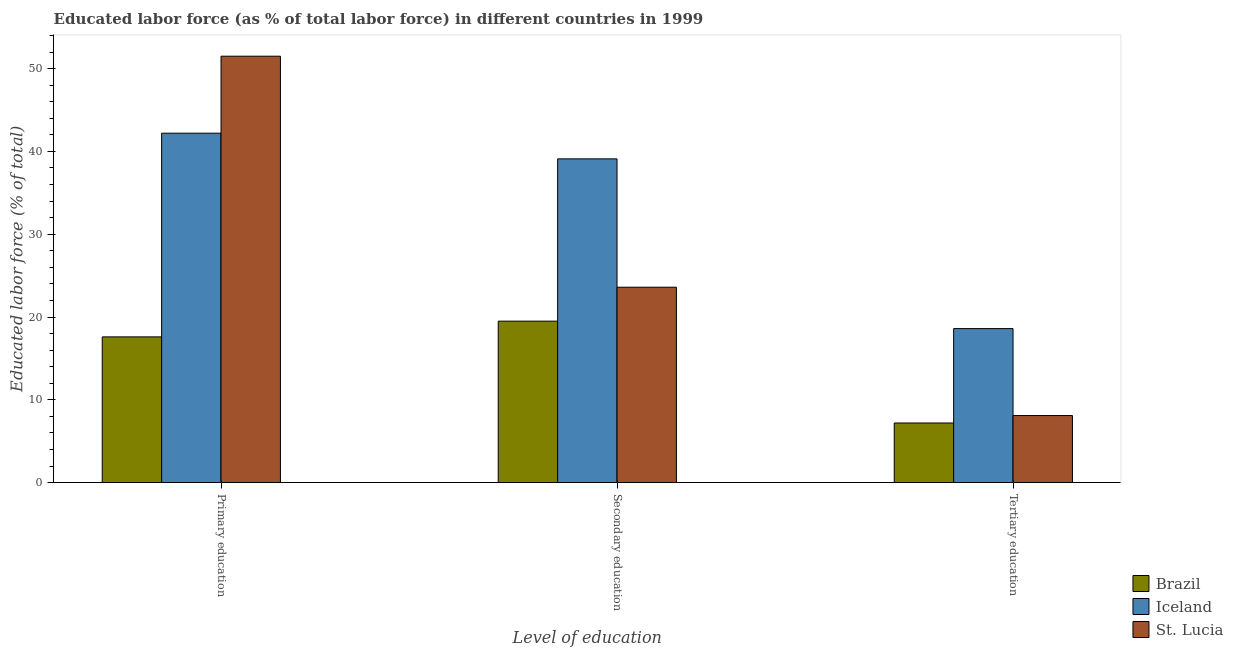How many different coloured bars are there?
Ensure brevity in your answer.  3. What is the label of the 2nd group of bars from the left?
Keep it short and to the point. Secondary education. What is the percentage of labor force who received primary education in Iceland?
Provide a succinct answer. 42.2. Across all countries, what is the maximum percentage of labor force who received tertiary education?
Provide a short and direct response. 18.6. In which country was the percentage of labor force who received tertiary education minimum?
Your answer should be very brief. Brazil. What is the total percentage of labor force who received primary education in the graph?
Your answer should be compact. 111.3. What is the difference between the percentage of labor force who received secondary education in Iceland and that in Brazil?
Your answer should be very brief. 19.6. What is the difference between the percentage of labor force who received primary education in Iceland and the percentage of labor force who received secondary education in St. Lucia?
Offer a terse response. 18.6. What is the average percentage of labor force who received tertiary education per country?
Offer a very short reply. 11.3. What is the difference between the percentage of labor force who received primary education and percentage of labor force who received secondary education in Iceland?
Keep it short and to the point. 3.1. What is the ratio of the percentage of labor force who received secondary education in Iceland to that in St. Lucia?
Make the answer very short. 1.66. Is the difference between the percentage of labor force who received primary education in Brazil and St. Lucia greater than the difference between the percentage of labor force who received tertiary education in Brazil and St. Lucia?
Keep it short and to the point. No. What is the difference between the highest and the second highest percentage of labor force who received primary education?
Keep it short and to the point. 9.3. What is the difference between the highest and the lowest percentage of labor force who received secondary education?
Give a very brief answer. 19.6. What does the 1st bar from the left in Tertiary education represents?
Offer a terse response. Brazil. What does the 1st bar from the right in Secondary education represents?
Keep it short and to the point. St. Lucia. Are all the bars in the graph horizontal?
Provide a short and direct response. No. Are the values on the major ticks of Y-axis written in scientific E-notation?
Your answer should be compact. No. Does the graph contain any zero values?
Provide a short and direct response. No. Where does the legend appear in the graph?
Your response must be concise. Bottom right. How many legend labels are there?
Make the answer very short. 3. What is the title of the graph?
Provide a succinct answer. Educated labor force (as % of total labor force) in different countries in 1999. Does "Guinea-Bissau" appear as one of the legend labels in the graph?
Your answer should be compact. No. What is the label or title of the X-axis?
Ensure brevity in your answer.  Level of education. What is the label or title of the Y-axis?
Provide a succinct answer. Educated labor force (% of total). What is the Educated labor force (% of total) of Brazil in Primary education?
Provide a succinct answer. 17.6. What is the Educated labor force (% of total) in Iceland in Primary education?
Provide a short and direct response. 42.2. What is the Educated labor force (% of total) of St. Lucia in Primary education?
Offer a very short reply. 51.5. What is the Educated labor force (% of total) of Iceland in Secondary education?
Provide a succinct answer. 39.1. What is the Educated labor force (% of total) of St. Lucia in Secondary education?
Make the answer very short. 23.6. What is the Educated labor force (% of total) of Brazil in Tertiary education?
Your answer should be compact. 7.2. What is the Educated labor force (% of total) in Iceland in Tertiary education?
Give a very brief answer. 18.6. What is the Educated labor force (% of total) in St. Lucia in Tertiary education?
Offer a very short reply. 8.1. Across all Level of education, what is the maximum Educated labor force (% of total) in Brazil?
Make the answer very short. 19.5. Across all Level of education, what is the maximum Educated labor force (% of total) in Iceland?
Ensure brevity in your answer.  42.2. Across all Level of education, what is the maximum Educated labor force (% of total) in St. Lucia?
Offer a terse response. 51.5. Across all Level of education, what is the minimum Educated labor force (% of total) of Brazil?
Offer a terse response. 7.2. Across all Level of education, what is the minimum Educated labor force (% of total) in Iceland?
Provide a short and direct response. 18.6. Across all Level of education, what is the minimum Educated labor force (% of total) of St. Lucia?
Make the answer very short. 8.1. What is the total Educated labor force (% of total) in Brazil in the graph?
Offer a very short reply. 44.3. What is the total Educated labor force (% of total) of Iceland in the graph?
Your answer should be compact. 99.9. What is the total Educated labor force (% of total) of St. Lucia in the graph?
Ensure brevity in your answer.  83.2. What is the difference between the Educated labor force (% of total) in Brazil in Primary education and that in Secondary education?
Ensure brevity in your answer.  -1.9. What is the difference between the Educated labor force (% of total) of St. Lucia in Primary education and that in Secondary education?
Your answer should be very brief. 27.9. What is the difference between the Educated labor force (% of total) of Iceland in Primary education and that in Tertiary education?
Offer a terse response. 23.6. What is the difference between the Educated labor force (% of total) of St. Lucia in Primary education and that in Tertiary education?
Your answer should be compact. 43.4. What is the difference between the Educated labor force (% of total) of Brazil in Secondary education and that in Tertiary education?
Your response must be concise. 12.3. What is the difference between the Educated labor force (% of total) in Iceland in Secondary education and that in Tertiary education?
Make the answer very short. 20.5. What is the difference between the Educated labor force (% of total) of Brazil in Primary education and the Educated labor force (% of total) of Iceland in Secondary education?
Your answer should be compact. -21.5. What is the difference between the Educated labor force (% of total) in Brazil in Primary education and the Educated labor force (% of total) in Iceland in Tertiary education?
Your response must be concise. -1. What is the difference between the Educated labor force (% of total) in Iceland in Primary education and the Educated labor force (% of total) in St. Lucia in Tertiary education?
Your answer should be compact. 34.1. What is the difference between the Educated labor force (% of total) of Iceland in Secondary education and the Educated labor force (% of total) of St. Lucia in Tertiary education?
Your answer should be very brief. 31. What is the average Educated labor force (% of total) in Brazil per Level of education?
Your response must be concise. 14.77. What is the average Educated labor force (% of total) of Iceland per Level of education?
Give a very brief answer. 33.3. What is the average Educated labor force (% of total) in St. Lucia per Level of education?
Offer a very short reply. 27.73. What is the difference between the Educated labor force (% of total) in Brazil and Educated labor force (% of total) in Iceland in Primary education?
Your answer should be very brief. -24.6. What is the difference between the Educated labor force (% of total) of Brazil and Educated labor force (% of total) of St. Lucia in Primary education?
Offer a very short reply. -33.9. What is the difference between the Educated labor force (% of total) of Brazil and Educated labor force (% of total) of Iceland in Secondary education?
Keep it short and to the point. -19.6. What is the difference between the Educated labor force (% of total) in Brazil and Educated labor force (% of total) in St. Lucia in Secondary education?
Offer a very short reply. -4.1. What is the difference between the Educated labor force (% of total) in Iceland and Educated labor force (% of total) in St. Lucia in Secondary education?
Give a very brief answer. 15.5. What is the difference between the Educated labor force (% of total) of Brazil and Educated labor force (% of total) of St. Lucia in Tertiary education?
Keep it short and to the point. -0.9. What is the difference between the Educated labor force (% of total) of Iceland and Educated labor force (% of total) of St. Lucia in Tertiary education?
Offer a very short reply. 10.5. What is the ratio of the Educated labor force (% of total) of Brazil in Primary education to that in Secondary education?
Your response must be concise. 0.9. What is the ratio of the Educated labor force (% of total) in Iceland in Primary education to that in Secondary education?
Your answer should be compact. 1.08. What is the ratio of the Educated labor force (% of total) in St. Lucia in Primary education to that in Secondary education?
Your answer should be compact. 2.18. What is the ratio of the Educated labor force (% of total) in Brazil in Primary education to that in Tertiary education?
Provide a succinct answer. 2.44. What is the ratio of the Educated labor force (% of total) in Iceland in Primary education to that in Tertiary education?
Give a very brief answer. 2.27. What is the ratio of the Educated labor force (% of total) in St. Lucia in Primary education to that in Tertiary education?
Offer a terse response. 6.36. What is the ratio of the Educated labor force (% of total) in Brazil in Secondary education to that in Tertiary education?
Offer a terse response. 2.71. What is the ratio of the Educated labor force (% of total) in Iceland in Secondary education to that in Tertiary education?
Offer a very short reply. 2.1. What is the ratio of the Educated labor force (% of total) of St. Lucia in Secondary education to that in Tertiary education?
Provide a succinct answer. 2.91. What is the difference between the highest and the second highest Educated labor force (% of total) in Brazil?
Provide a short and direct response. 1.9. What is the difference between the highest and the second highest Educated labor force (% of total) of Iceland?
Provide a short and direct response. 3.1. What is the difference between the highest and the second highest Educated labor force (% of total) in St. Lucia?
Your answer should be compact. 27.9. What is the difference between the highest and the lowest Educated labor force (% of total) of Iceland?
Your response must be concise. 23.6. What is the difference between the highest and the lowest Educated labor force (% of total) of St. Lucia?
Your response must be concise. 43.4. 